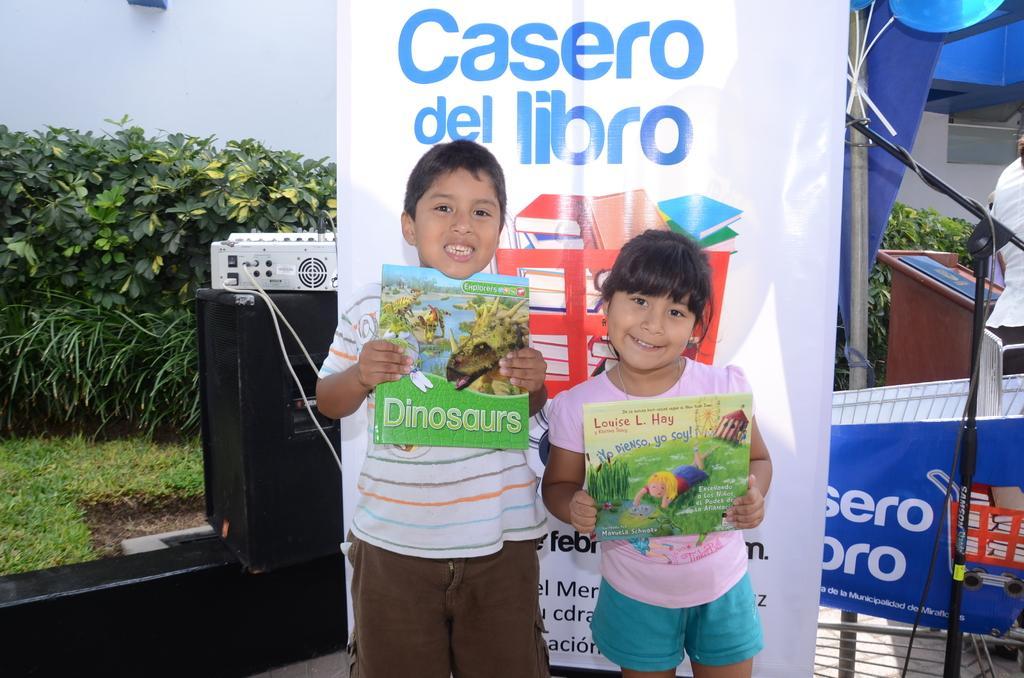In one or two sentences, can you explain what this image depicts? This picture consists of two children's holding papers and they both are open their mouth and in the background I can see a pomp let , on the pomp let I can see text and I can see mike ,person ,bushes, board visible on right side and on left side I can see the wall, bush's ,speakers ,grass. 